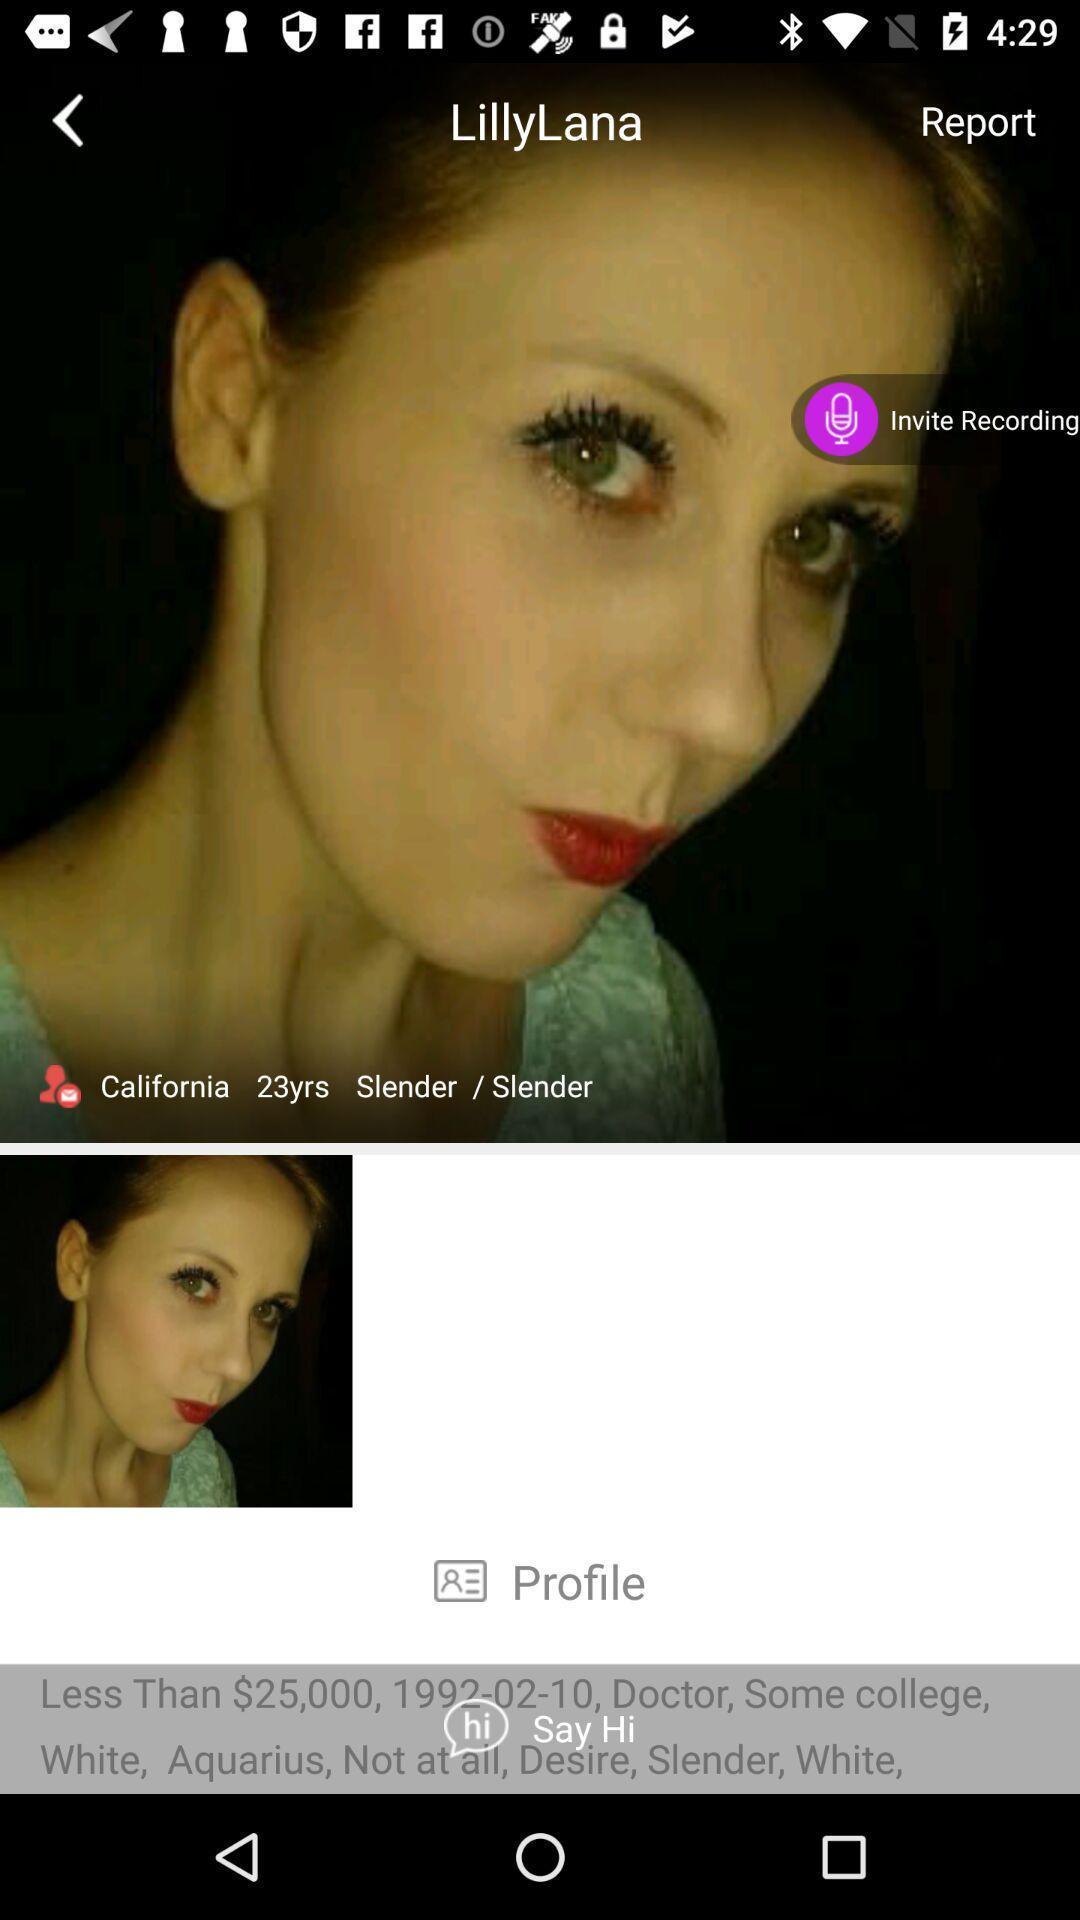Please provide a description for this image. Page displaying with image and profile details. 